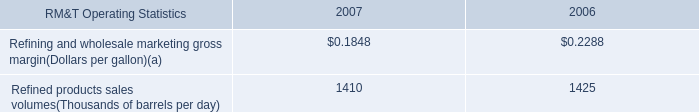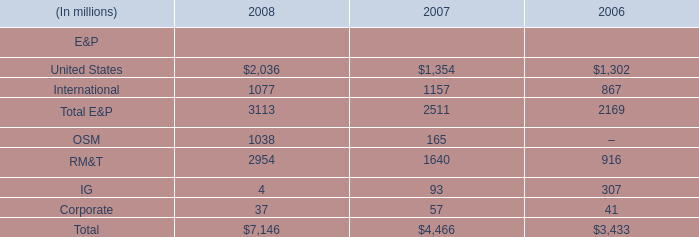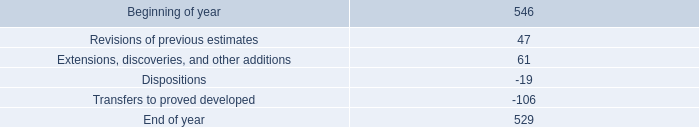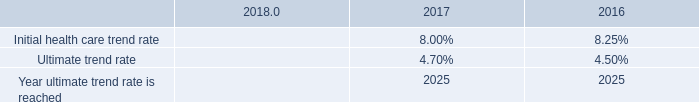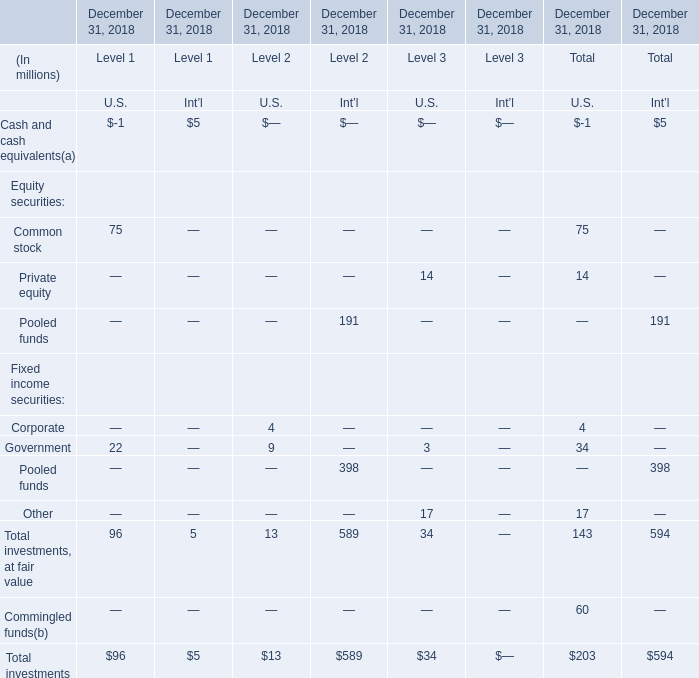In which Level is Total investments for U.S. at December 31, 2018 smaller than 20 million? 
Answer: 2. 